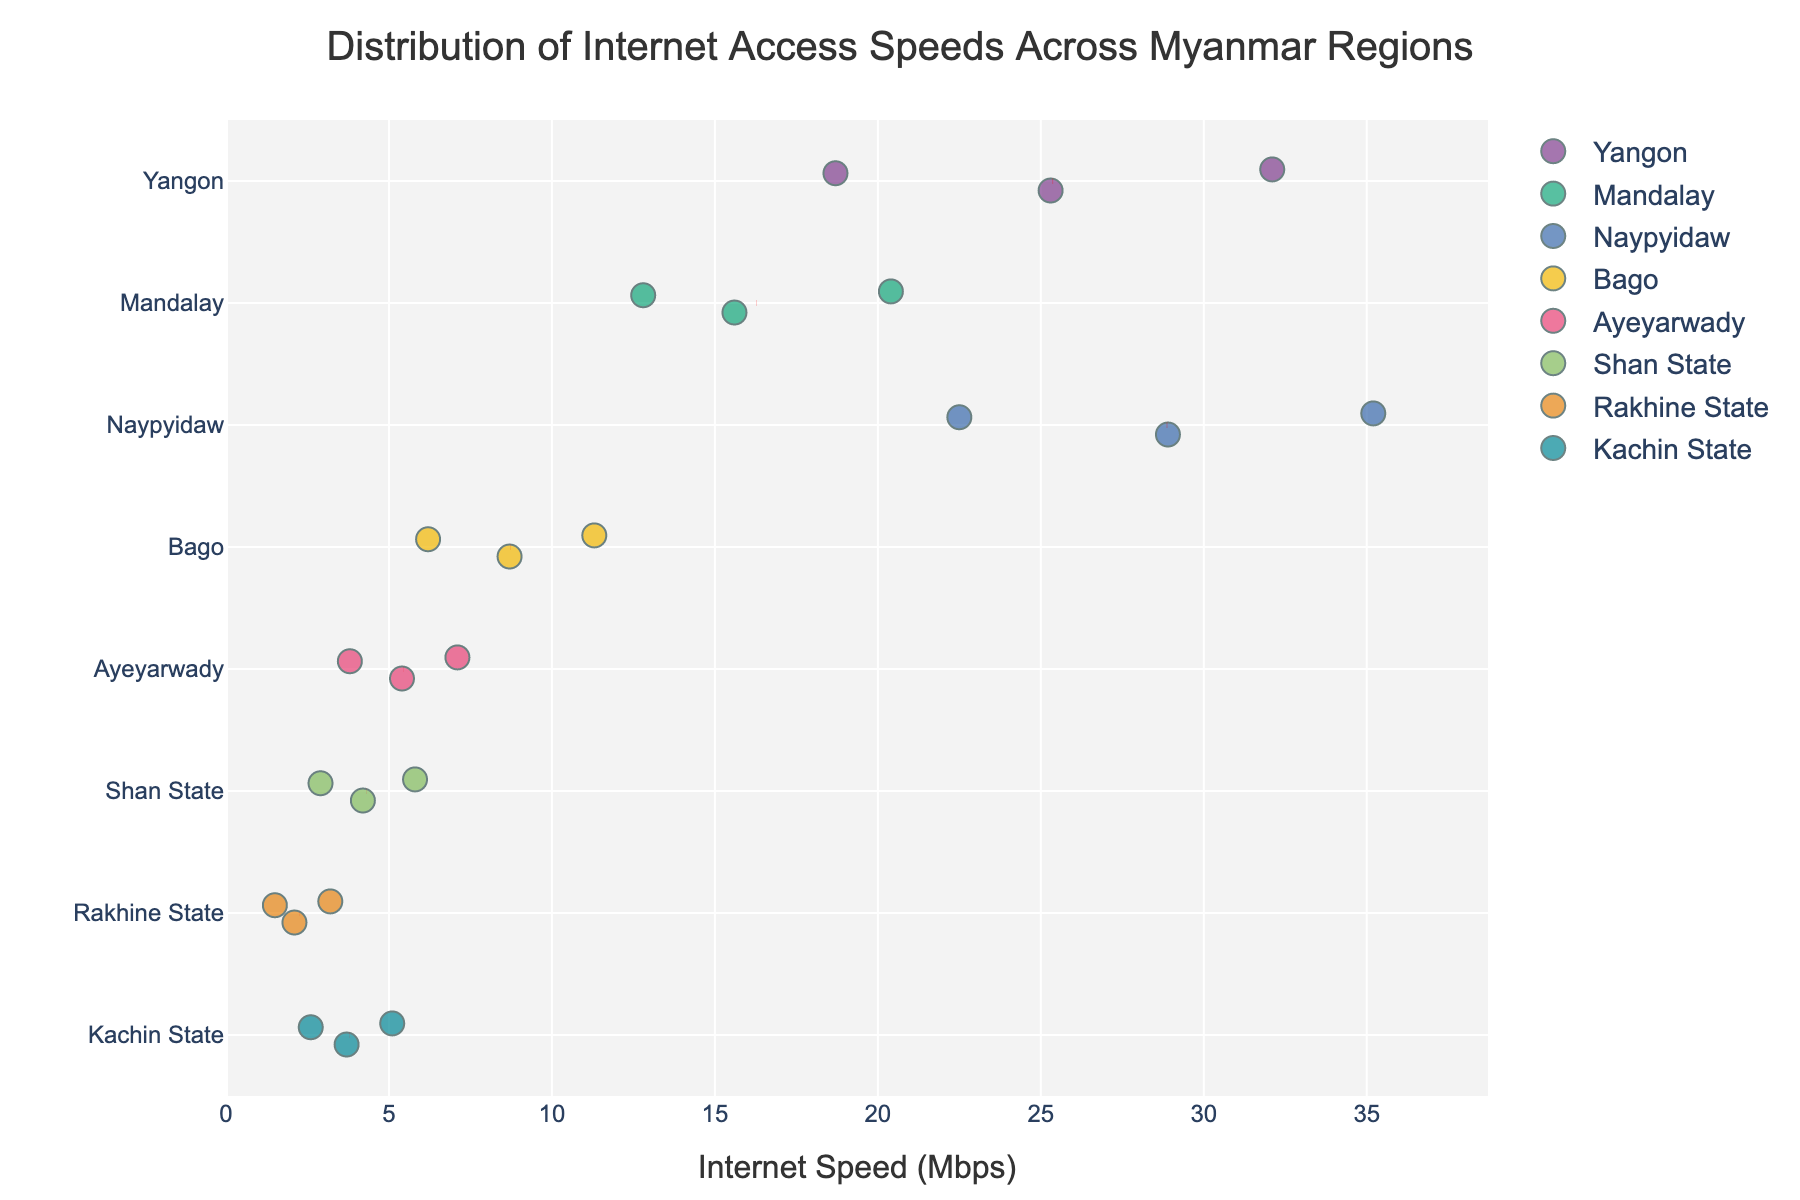What's the title of the figure? The title of the figure is located at the top center of the plot and is usually the most prominent text.
Answer: Distribution of Internet Access Speeds Across Myanmar Regions How many data points represent the Yangon region? By examining the number of points plotted horizontally along the 'Yangon' row, we can count the data points.
Answer: 3 Which region has the highest internet speed? We need to look at the rightmost point in the entire plot to determine the highest value and see which region it belongs to.
Answer: Naypyidaw What is the average internet speed in Mandalay? Sum the speeds for Mandalay (15.6, 12.8, 20.4) and divide by the total number of data points (3). Calculation: (15.6 + 12.8 + 20.4) / 3 = 16.27
Answer: 16.27 Mbps Which region has the lowest average internet speed? Calculate the average speed for each region and compare them to identify the lowest one. For Rakhine State: (2.1 + 1.5 + 3.2) / 3 = 2.27; for Shan State: (4.2 + 2.9 + 5.8) / 3 = 4.3; for Bago: (8.7 + 6.2 + 11.3) / 3 = 8.73; and so on. The region with the lowest value is Rakhine State.
Answer: Rakhine State How does the internet speed distribution in Yangon compare to Ayeyarwady? Compare the range and the spread of the data points for both regions. Yangon's speeds range from 18.7 to 32.1 Mbps and are more spread out, while Ayeyarwady's range from 3.8 to 7.1 Mbps and are closer together. This shows Yangon has higher and more varied speeds.
Answer: Yangon has higher and more varied speeds than Ayeyarwady What is the mean internet speed in Naypyidaw, as indicated by the red dashed line? Identify the position of the red dashed line on the Naypyidaw row, which marks the mean speed for that region.
Answer: 28.87 Mbps How does the internet speed in Bago compare to Kachin State? Examination of the position and spread of points along the 'Bago' and 'Kachin State' rows indicates Bago has higher internet speeds with less spread (6.2 - 11.3 Mbps) compared to Kachin State (2.6 - 5.1 Mbps).
Answer: Bago has higher internet speeds than Kachin State Which region has the most consistent (least variable) internet speeds? Determine the consistency by measuring the spread of data points. The region with points closest together (least spread) is typically the most consistent.
Answer: Rakhine State What is the color used to represent Mandalay region in the plot? By closely inspecting the color of the points within the horizontal 'Mandalay' row, we can identify the specific color used.
Answer: Likely a specific bold color from the qualitative palette, e.g., green 